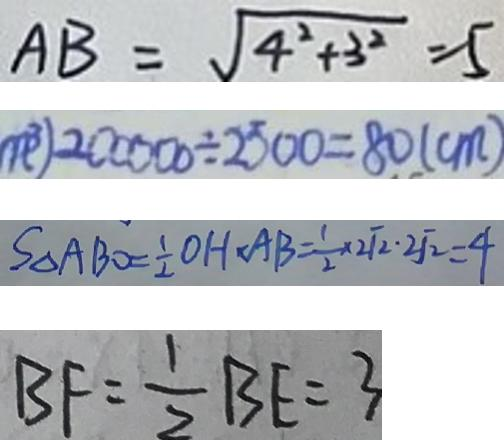<formula> <loc_0><loc_0><loc_500><loc_500>A B = \sqrt { 4 ^ { 2 } + 3 ^ { 2 } } = 5 
 m ^ { 3 } ) 2 0 0 0 0 0 \div 2 5 0 0 = 8 0 ( c m ) 
 S \Delta A B O = \frac { 1 } { 2 } O H \cdot A B = \frac { 1 } { 2 } \times \sqrt [ 2 ] { 2 } . \sqrt [ 2 ] { 2 } = 4 
 B F = \frac { 1 } { 2 } B E = 3</formula> 